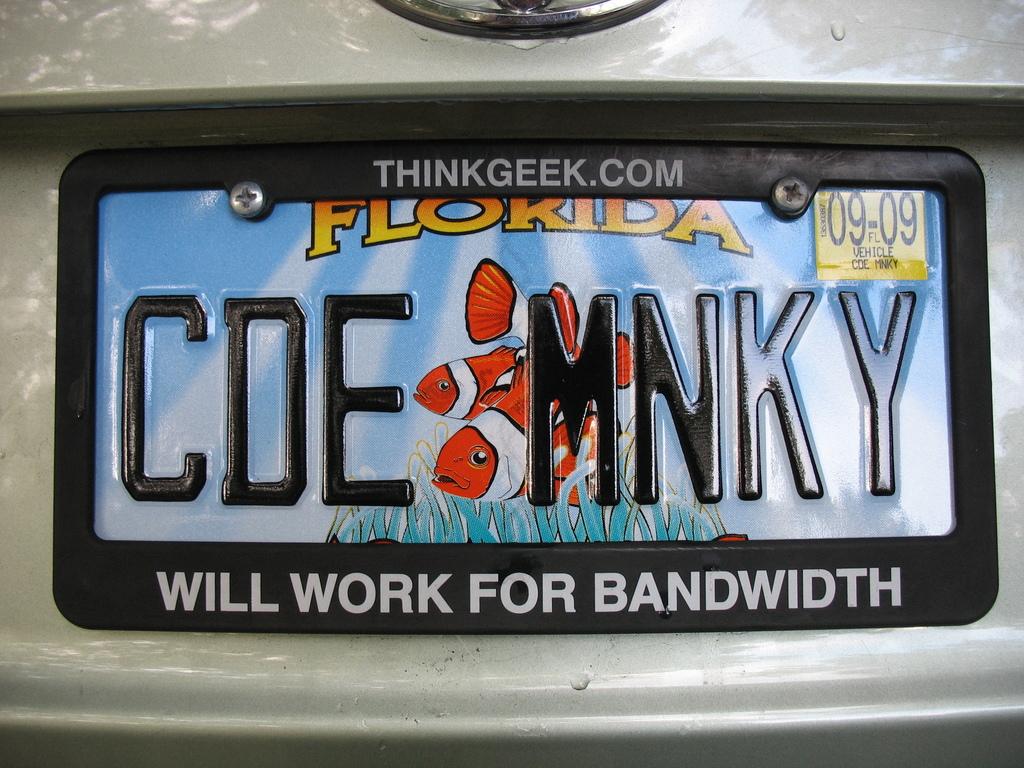What name is on car tag?
Make the answer very short. Cde mnky. What state is the plate from?
Your answer should be compact. Florida. 